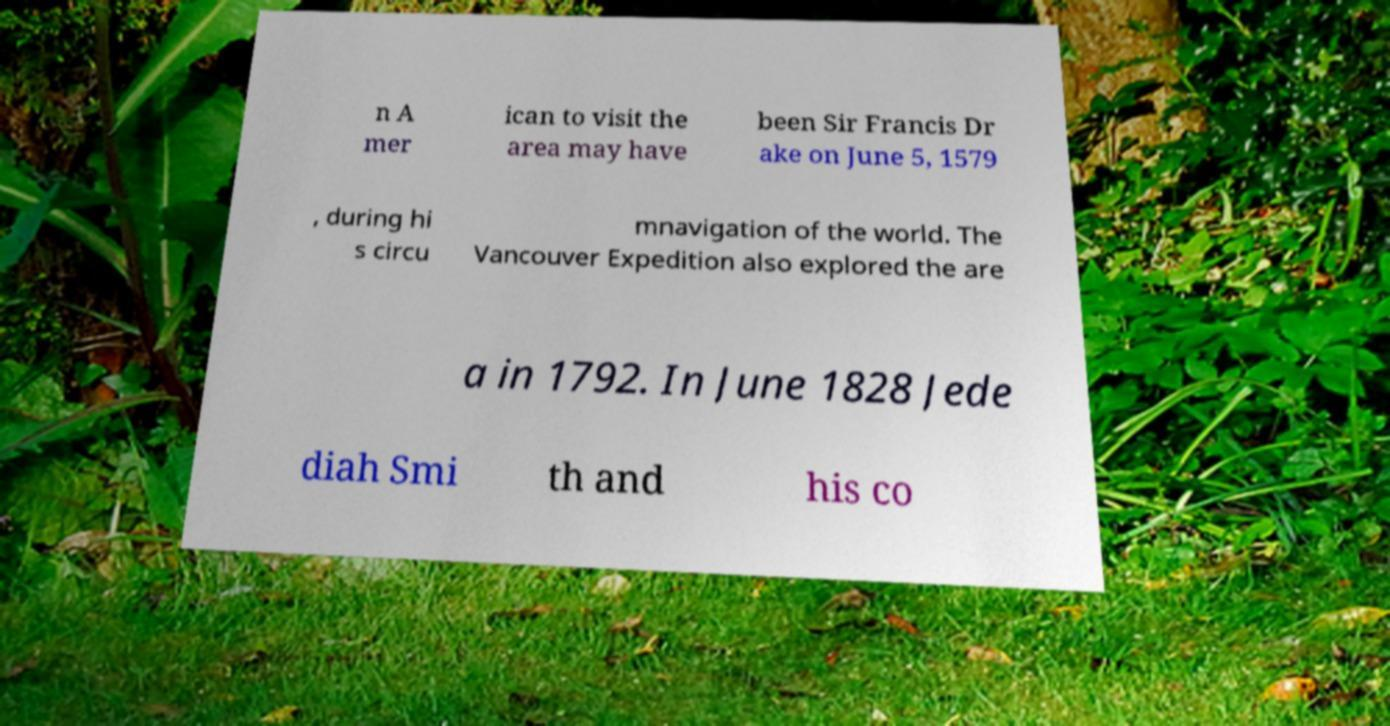Could you assist in decoding the text presented in this image and type it out clearly? n A mer ican to visit the area may have been Sir Francis Dr ake on June 5, 1579 , during hi s circu mnavigation of the world. The Vancouver Expedition also explored the are a in 1792. In June 1828 Jede diah Smi th and his co 